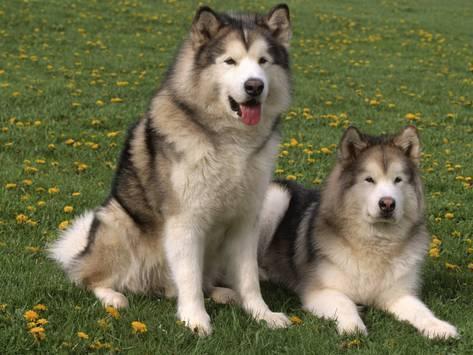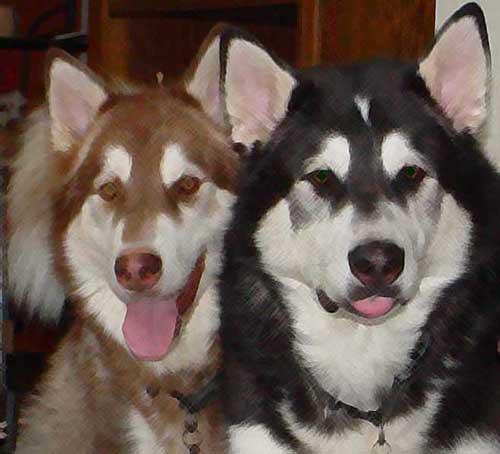The first image is the image on the left, the second image is the image on the right. Evaluate the accuracy of this statement regarding the images: "There are four dogs.". Is it true? Answer yes or no. Yes. The first image is the image on the left, the second image is the image on the right. Assess this claim about the two images: "There is a total of four dogs.". Correct or not? Answer yes or no. Yes. 